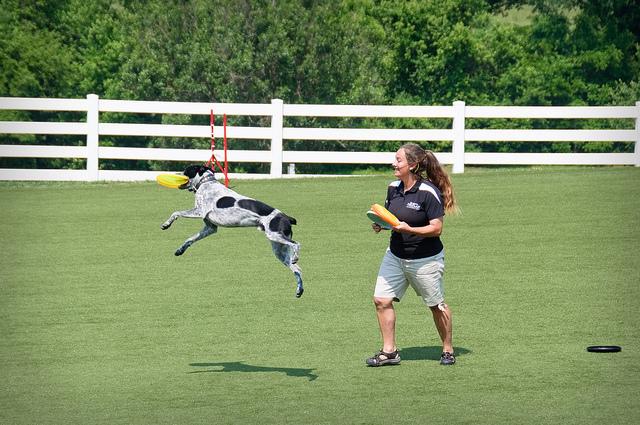Does the dog have a shadow?
Write a very short answer. Yes. Does this lady have long hair?
Be succinct. Yes. What is the dog doing?
Concise answer only. Catching frisbee. 